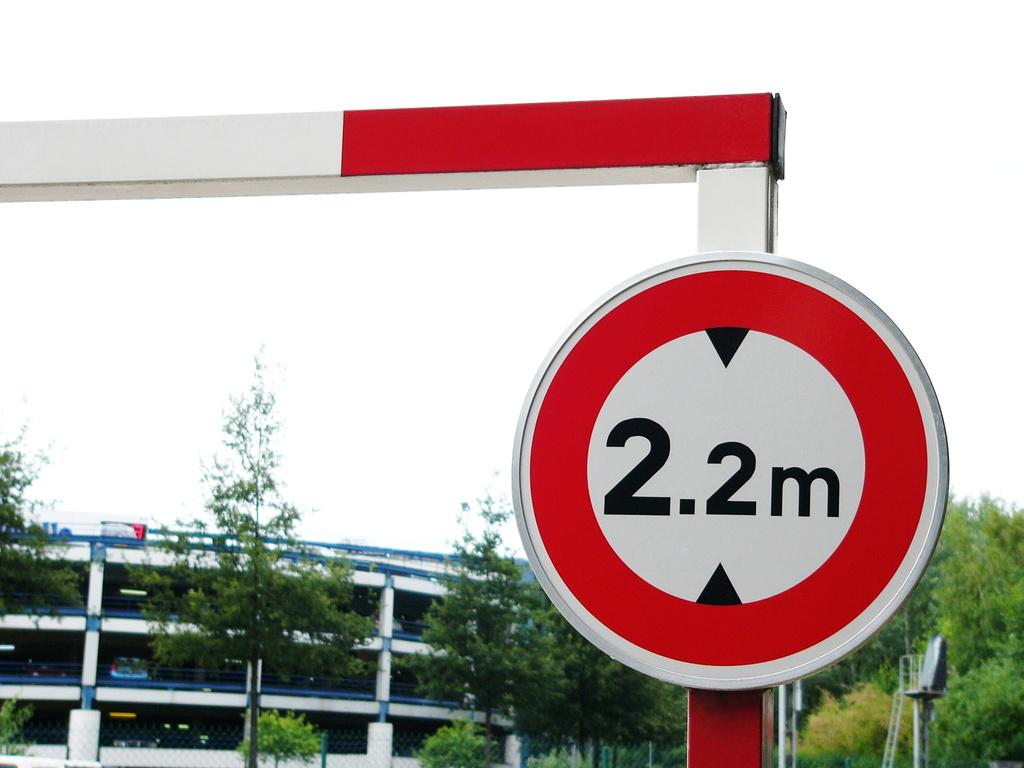What is the main object in the image? There is a sign board in the image. What can be seen in the sky in the image? The sky is visible in the image. What type of structure is present in the image? There is a building in the image. What type of vegetation is present in the image? Trees are present in the image. What type of pancake can be seen folded in the image? There is no pancake present in the image. What thought is being expressed by the trees in the image? Trees do not express thoughts; they are inanimate objects. 